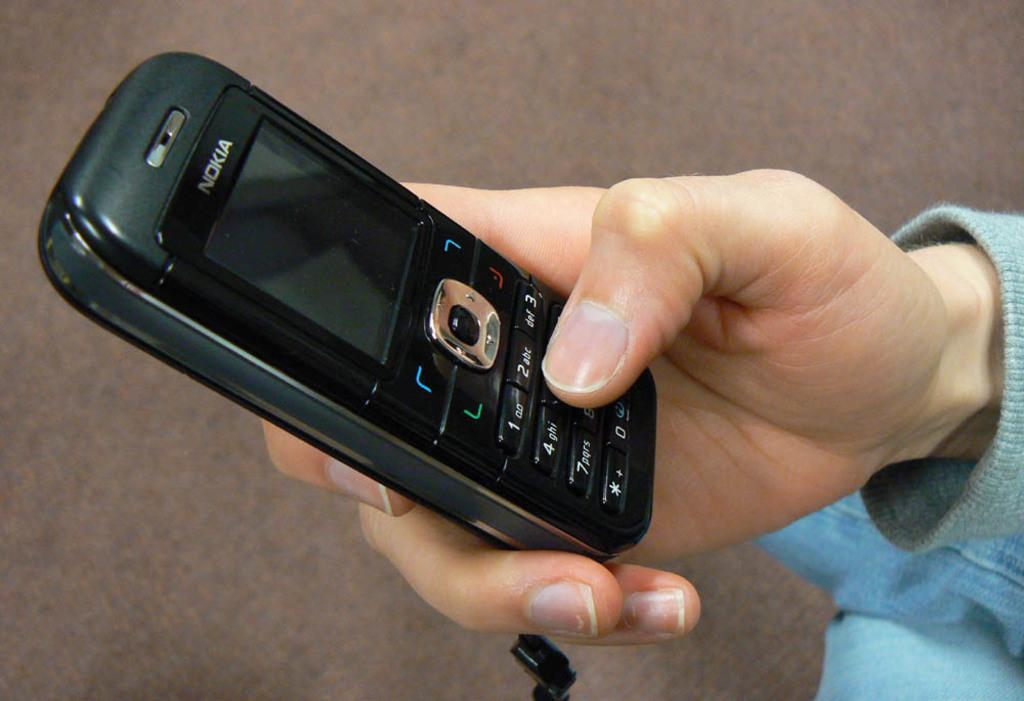What part of a person can be seen in the image? There is a hand of a person in the image. What is the person holding in the image? The person is holding a mobile phone. What type of cattle can be seen grazing on the stage in the image? There is no stage or cattle present in the image; it only features a hand holding a mobile phone. 